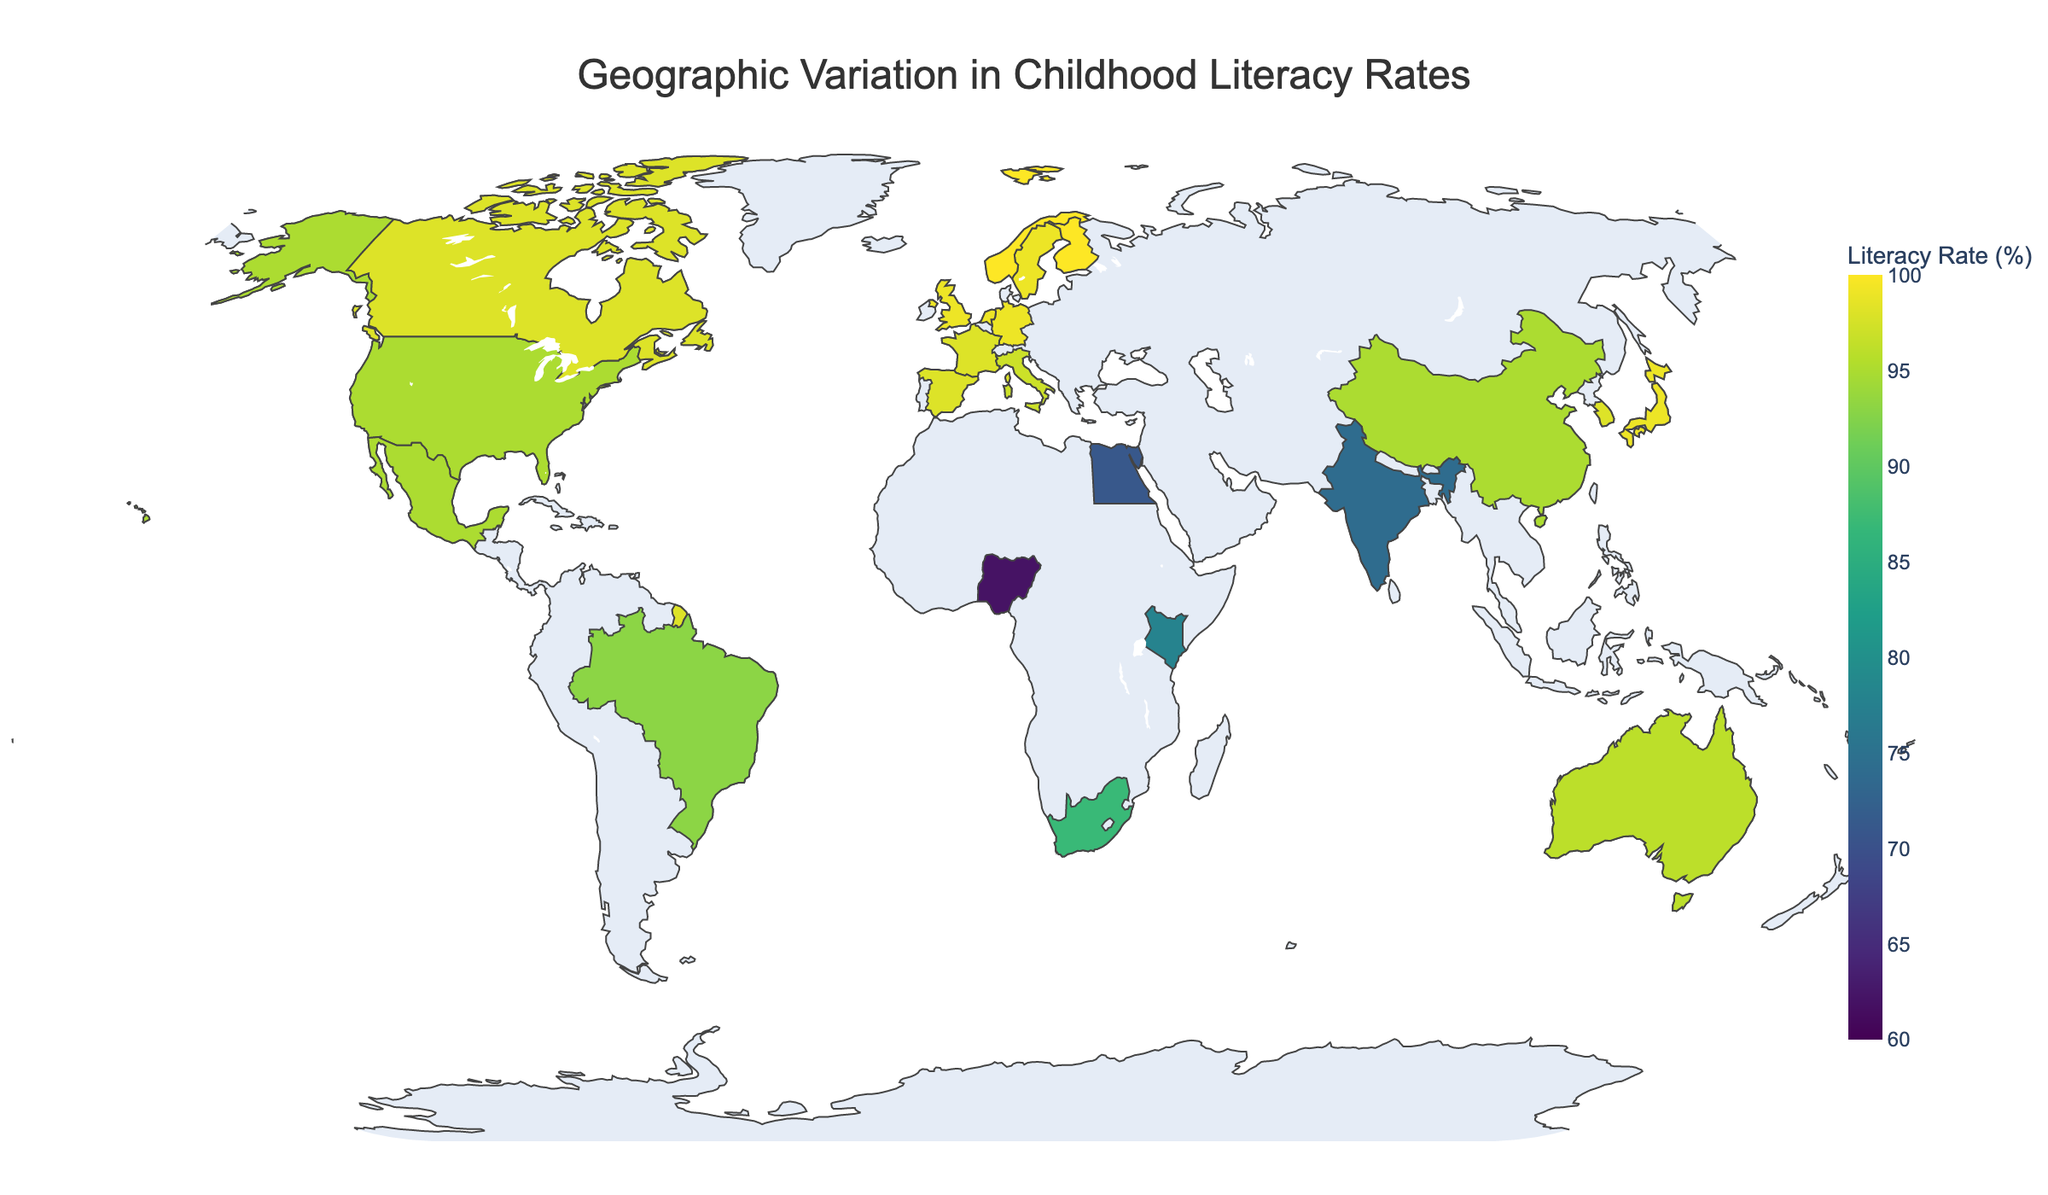What is the title of the figure? The title is usually located at the top of the figure. By reading it, we can understand the overall subject of the map.
Answer: Geographic Variation in Childhood Literacy Rates Which country has the highest childhood literacy rate? We need to look for countries with the darkest colors in the specified color range (60 to 100) and check their literacy rates. Finland and Norway both have 100%.
Answer: Finland, Norway Which country has the lowest childhood literacy rate? We need to look for the country with the lightest color in the specified color range and check its literacy rate. Nigeria shows the lowest value at 62%.
Answer: Nigeria How many countries have a literacy rate of 99%? We need to count the number of countries that fall under the 99% literacy rate. These countries are: United Kingdom, Japan, Germany, Sweden, Netherlands.
Answer: 5 What is the difference in literacy rate between the highest and lowest countries? The highest literacy rate is 100% (Finland, Norway), and the lowest is 62% (Nigeria). The difference is 100 - 62 = 38.
Answer: 38 Which two countries have the same literacy rate of 98%? By scanning the colors and hover-tips, we observe that Canada, France, Spain, and South Korea all have a literacy rate of 98%.
Answer: Canada, France, Spain, South Korea What is the average literacy rate across all countries shown? Add up all the literacy rates and divide by the total number of countries (22). The sum is 1686, and the average is calculated as 1686 / 22.
Answer: 76.64% Name three countries with a literacy rate above 95% but below 100%. Identify countries with literacy rates between 96% and 99%. Suitable countries are Australia, Italy, and South Korea.
Answer: Australia, Italy, South Korea Which continents seem to have more countries with high literacy rates? Observe the distribution of countries with the highest literacy rates (dark colors). Europe has the most countries with literacy rates close to or at 100%, indicated by darker colors in that region.
Answer: Europe Is there a significant difference in the literacy rates of countries in Africa compared to countries in Europe? Compare the literacy rates in Africa (e.g., South Africa 87%, Kenya 78%, Nigeria 62%, Egypt 71%) with those in Europe (e.g., United Kingdom 99%, Germany 99%, France 98%, Sweden 99%). European countries have higher rates on average.
Answer: Yes 